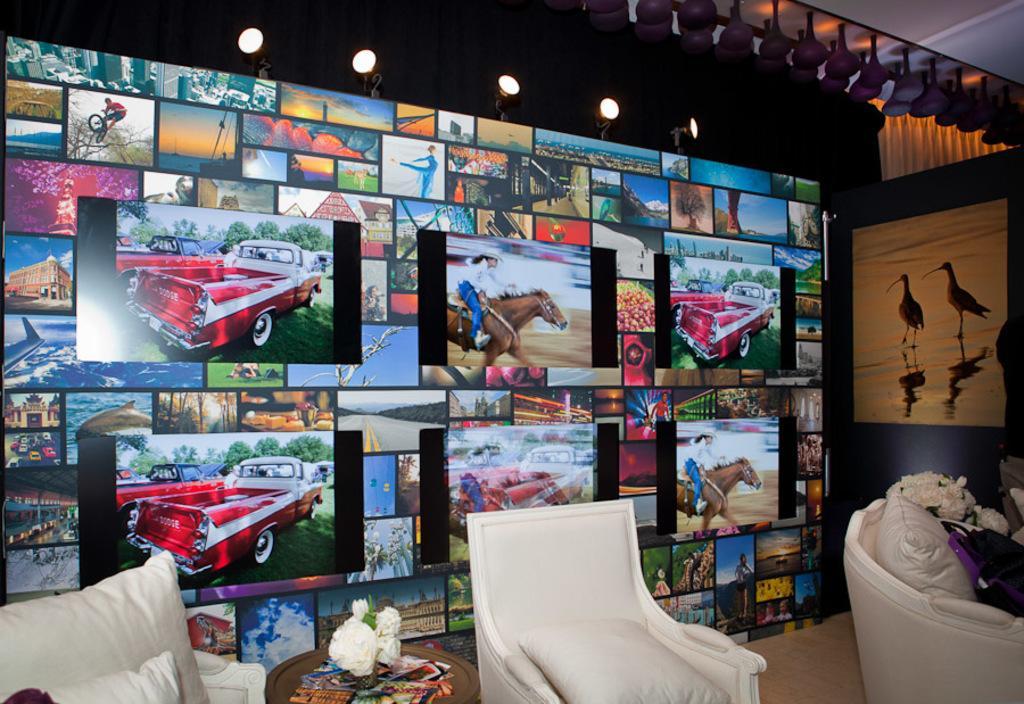In one or two sentences, can you explain what this image depicts? In this picture I can see there are few chairs and there is a table and there are few objects placed on the table and there are few photo frames placed on the wall and there are pictures of cars, buildings, horses and airplane and there is a picture of birds on to right. 